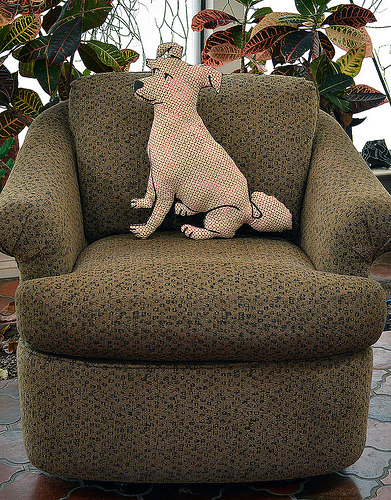<image>
Is there a pillow in the chair? Yes. The pillow is contained within or inside the chair, showing a containment relationship. Is the toy on the sofa? Yes. Looking at the image, I can see the toy is positioned on top of the sofa, with the sofa providing support. Where is the dog pillow in relation to the chair? Is it on the chair? Yes. Looking at the image, I can see the dog pillow is positioned on top of the chair, with the chair providing support. 